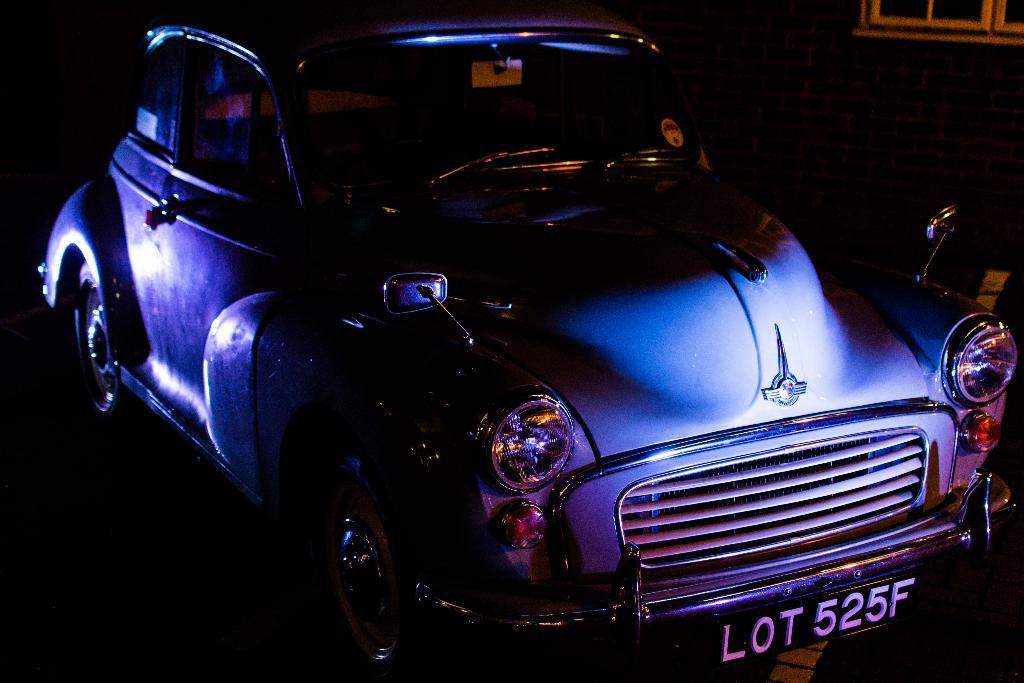What is the main subject of the picture? The main subject of the picture is a car. What can be seen on the right side of the picture? There are windows and a wall on the right side of the picture. What type of tramp is visible in the picture? There is no tramp present in the picture; it features a car and windows on the right side of the image. How does the car's brake system appear in the picture? The provided facts do not mention the car's brake system, so it cannot be determined from the image. 